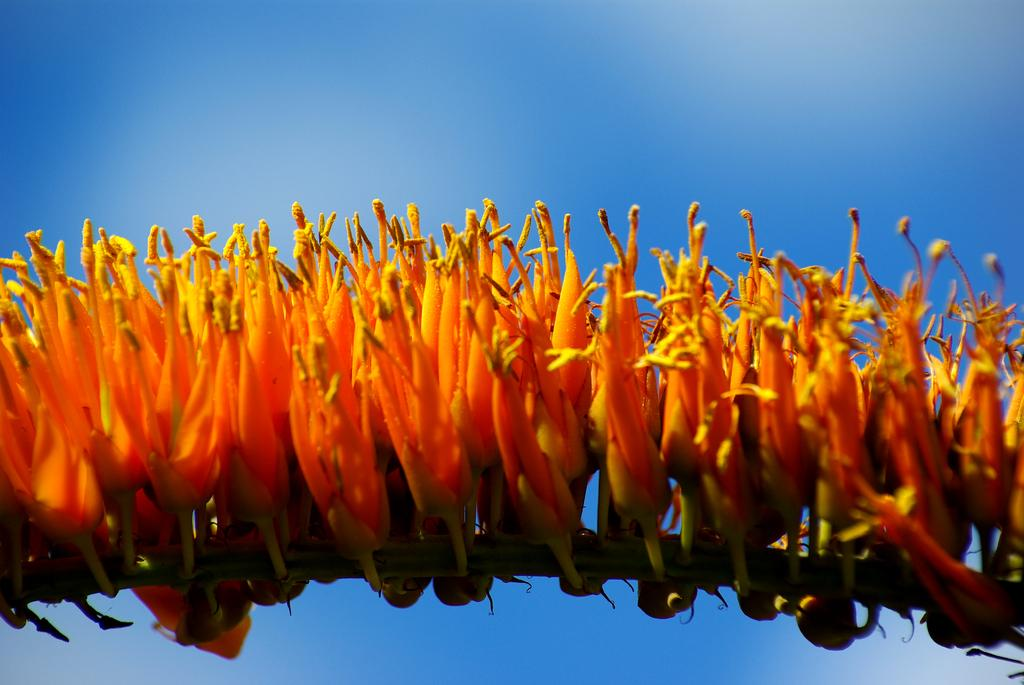What type of plant is visible in the image? There are flowers on the plant in the image. What colors are the flowers on the plant? The flowers are in yellow and orange colors. What color is the background in the image? There is a blue background in the image. What type of notebook is being used in the image? There is no notebook present in the image. What type of grip is required to hold the plant in the image? The image does not show any need for a grip, as the plant is stationary and not being held. 